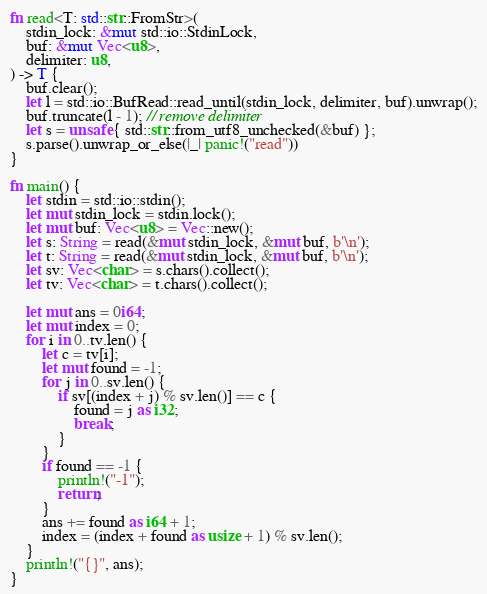Convert code to text. <code><loc_0><loc_0><loc_500><loc_500><_Rust_>fn read<T: std::str::FromStr>(
    stdin_lock: &mut std::io::StdinLock,
    buf: &mut Vec<u8>,
    delimiter: u8,
) -> T {
    buf.clear();
    let l = std::io::BufRead::read_until(stdin_lock, delimiter, buf).unwrap();
    buf.truncate(l - 1); // remove delimiter
    let s = unsafe { std::str::from_utf8_unchecked(&buf) };
    s.parse().unwrap_or_else(|_| panic!("read"))
}

fn main() {
    let stdin = std::io::stdin();
    let mut stdin_lock = stdin.lock();
    let mut buf: Vec<u8> = Vec::new();
    let s: String = read(&mut stdin_lock, &mut buf, b'\n');
    let t: String = read(&mut stdin_lock, &mut buf, b'\n');
    let sv: Vec<char> = s.chars().collect();
    let tv: Vec<char> = t.chars().collect();

    let mut ans = 0i64;
    let mut index = 0;
    for i in 0..tv.len() {
        let c = tv[i];
        let mut found = -1;
        for j in 0..sv.len() {
            if sv[(index + j) % sv.len()] == c {
                found = j as i32;
                break;
            }
        }
        if found == -1 {
            println!("-1");
            return;
        }
        ans += found as i64 + 1;
        index = (index + found as usize + 1) % sv.len();
    }
    println!("{}", ans);
}
</code> 